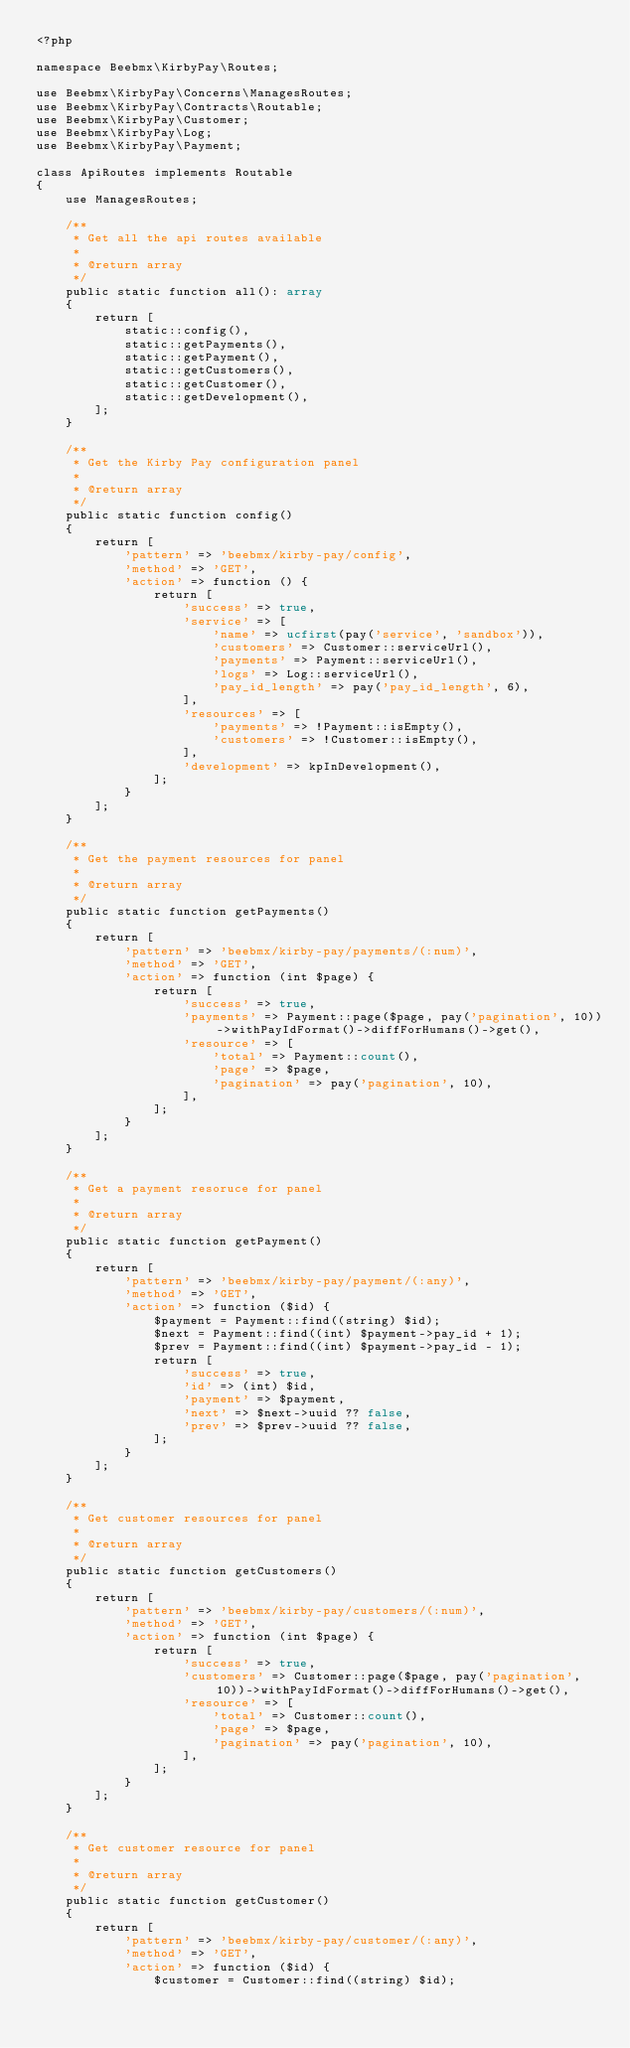Convert code to text. <code><loc_0><loc_0><loc_500><loc_500><_PHP_><?php

namespace Beebmx\KirbyPay\Routes;

use Beebmx\KirbyPay\Concerns\ManagesRoutes;
use Beebmx\KirbyPay\Contracts\Routable;
use Beebmx\KirbyPay\Customer;
use Beebmx\KirbyPay\Log;
use Beebmx\KirbyPay\Payment;

class ApiRoutes implements Routable
{
    use ManagesRoutes;

    /**
     * Get all the api routes available
     *
     * @return array
     */
    public static function all(): array
    {
        return [
            static::config(),
            static::getPayments(),
            static::getPayment(),
            static::getCustomers(),
            static::getCustomer(),
            static::getDevelopment(),
        ];
    }

    /**
     * Get the Kirby Pay configuration panel
     *
     * @return array
     */
    public static function config()
    {
        return [
            'pattern' => 'beebmx/kirby-pay/config',
            'method' => 'GET',
            'action' => function () {
                return [
                    'success' => true,
                    'service' => [
                        'name' => ucfirst(pay('service', 'sandbox')),
                        'customers' => Customer::serviceUrl(),
                        'payments' => Payment::serviceUrl(),
                        'logs' => Log::serviceUrl(),
                        'pay_id_length' => pay('pay_id_length', 6),
                    ],
                    'resources' => [
                        'payments' => !Payment::isEmpty(),
                        'customers' => !Customer::isEmpty(),
                    ],
                    'development' => kpInDevelopment(),
                ];
            }
        ];
    }

    /**
     * Get the payment resources for panel
     *
     * @return array
     */
    public static function getPayments()
    {
        return [
            'pattern' => 'beebmx/kirby-pay/payments/(:num)',
            'method' => 'GET',
            'action' => function (int $page) {
                return [
                    'success' => true,
                    'payments' => Payment::page($page, pay('pagination', 10))->withPayIdFormat()->diffForHumans()->get(),
                    'resource' => [
                        'total' => Payment::count(),
                        'page' => $page,
                        'pagination' => pay('pagination', 10),
                    ],
                ];
            }
        ];
    }

    /**
     * Get a payment resoruce for panel
     *
     * @return array
     */
    public static function getPayment()
    {
        return [
            'pattern' => 'beebmx/kirby-pay/payment/(:any)',
            'method' => 'GET',
            'action' => function ($id) {
                $payment = Payment::find((string) $id);
                $next = Payment::find((int) $payment->pay_id + 1);
                $prev = Payment::find((int) $payment->pay_id - 1);
                return [
                    'success' => true,
                    'id' => (int) $id,
                    'payment' => $payment,
                    'next' => $next->uuid ?? false,
                    'prev' => $prev->uuid ?? false,
                ];
            }
        ];
    }

    /**
     * Get customer resources for panel
     *
     * @return array
     */
    public static function getCustomers()
    {
        return [
            'pattern' => 'beebmx/kirby-pay/customers/(:num)',
            'method' => 'GET',
            'action' => function (int $page) {
                return [
                    'success' => true,
                    'customers' => Customer::page($page, pay('pagination', 10))->withPayIdFormat()->diffForHumans()->get(),
                    'resource' => [
                        'total' => Customer::count(),
                        'page' => $page,
                        'pagination' => pay('pagination', 10),
                    ],
                ];
            }
        ];
    }

    /**
     * Get customer resource for panel
     *
     * @return array
     */
    public static function getCustomer()
    {
        return [
            'pattern' => 'beebmx/kirby-pay/customer/(:any)',
            'method' => 'GET',
            'action' => function ($id) {
                $customer = Customer::find((string) $id);</code> 